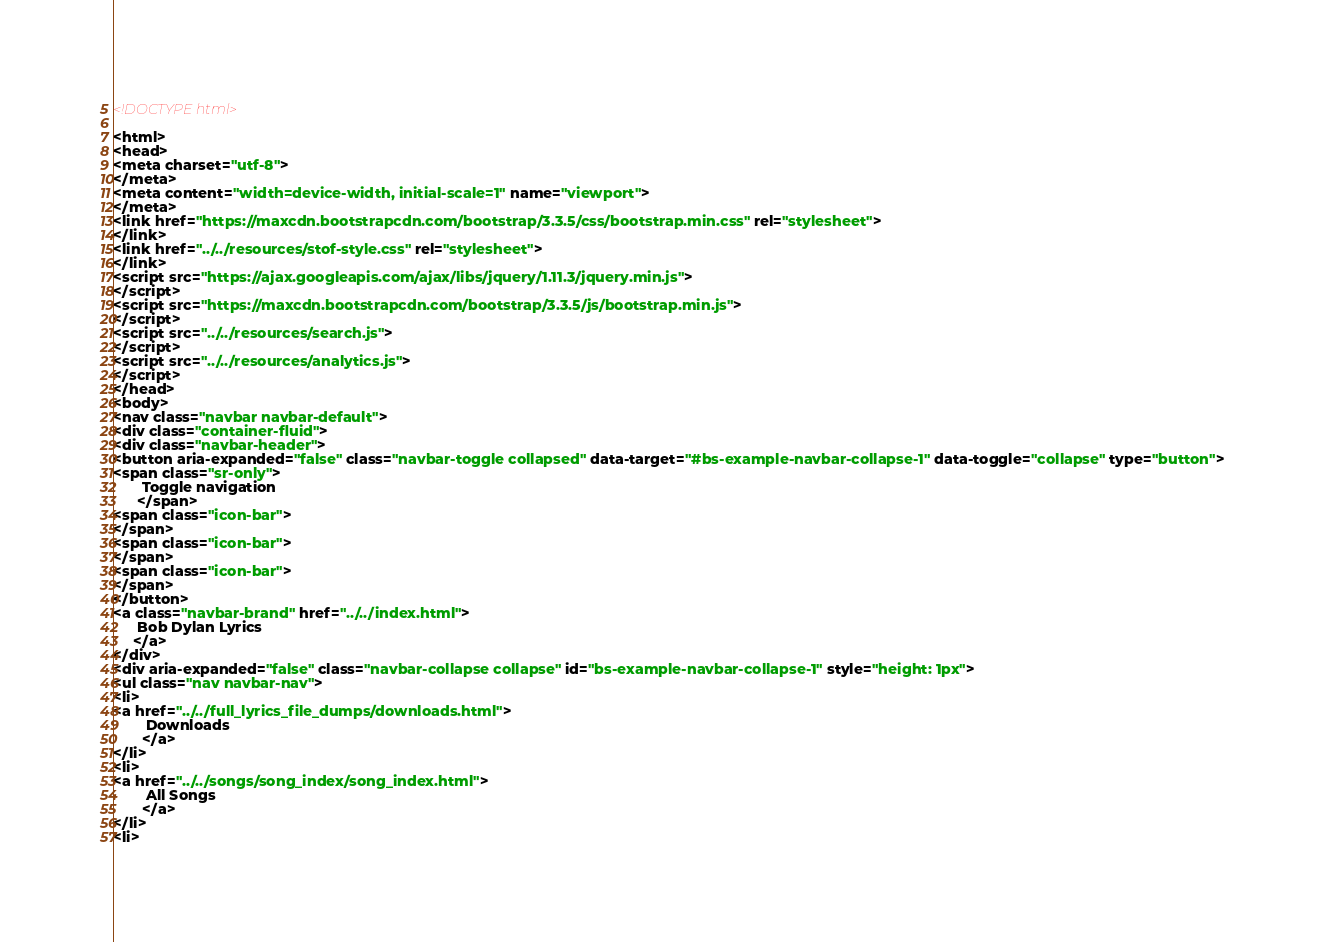<code> <loc_0><loc_0><loc_500><loc_500><_HTML_><!DOCTYPE html>

<html>
<head>
<meta charset="utf-8">
</meta>
<meta content="width=device-width, initial-scale=1" name="viewport">
</meta>
<link href="https://maxcdn.bootstrapcdn.com/bootstrap/3.3.5/css/bootstrap.min.css" rel="stylesheet">
</link>
<link href="../../resources/stof-style.css" rel="stylesheet">
</link>
<script src="https://ajax.googleapis.com/ajax/libs/jquery/1.11.3/jquery.min.js">
</script>
<script src="https://maxcdn.bootstrapcdn.com/bootstrap/3.3.5/js/bootstrap.min.js">
</script>
<script src="../../resources/search.js">
</script>
<script src="../../resources/analytics.js">
</script>
</head>
<body>
<nav class="navbar navbar-default">
<div class="container-fluid">
<div class="navbar-header">
<button aria-expanded="false" class="navbar-toggle collapsed" data-target="#bs-example-navbar-collapse-1" data-toggle="collapse" type="button">
<span class="sr-only">
       Toggle navigation
      </span>
<span class="icon-bar">
</span>
<span class="icon-bar">
</span>
<span class="icon-bar">
</span>
</button>
<a class="navbar-brand" href="../../index.html">
      Bob Dylan Lyrics
     </a>
</div>
<div aria-expanded="false" class="navbar-collapse collapse" id="bs-example-navbar-collapse-1" style="height: 1px">
<ul class="nav navbar-nav">
<li>
<a href="../../full_lyrics_file_dumps/downloads.html">
        Downloads
       </a>
</li>
<li>
<a href="../../songs/song_index/song_index.html">
        All Songs
       </a>
</li>
<li></code> 